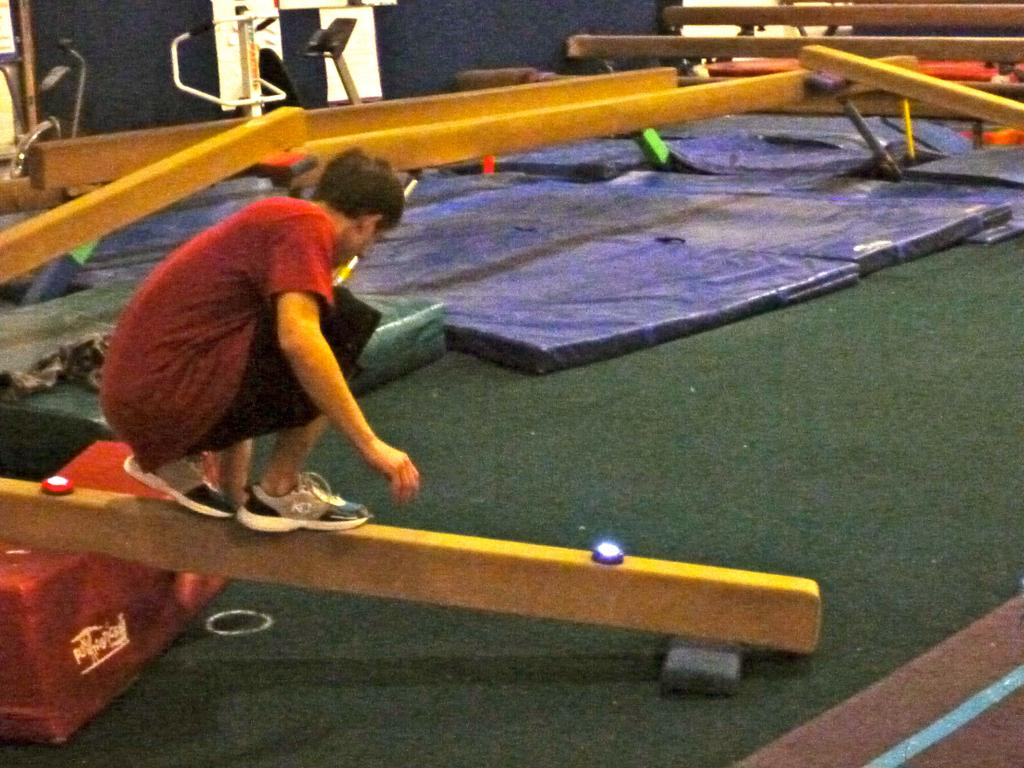What is the main subject of the image? The main subject of the image is a boy. What is the boy doing in the image? The boy is standing on a bar. What is the boy wearing in the image? The boy is wearing a t-shirt, shorts, and shoes. What can be seen at the bar in the image? There are lights at the bar and blue color sheets at the top of the bar. What type of stomach ache is the boy experiencing in the image? There is no indication in the image that the boy is experiencing any stomach ache. What channel is the boy watching on the bar? There is no television or channel present in the image; it only shows a boy standing on a bar with lights and blue color sheets. 